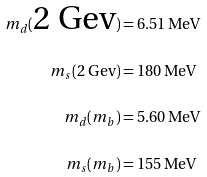Convert formula to latex. <formula><loc_0><loc_0><loc_500><loc_500>m _ { d } ( \text {2 Gev} ) & = 6 . 5 1 \, \text {MeV} \\ m _ { s } ( \text {2 Gev} ) & = 1 8 0 \, \text {MeV} \\ \quad m _ { d } ( m _ { b } ) & = 5 . 6 0 \, \text {MeV} \\ m _ { s } ( m _ { b } ) & = 1 5 5 \, \text {MeV} \\</formula> 